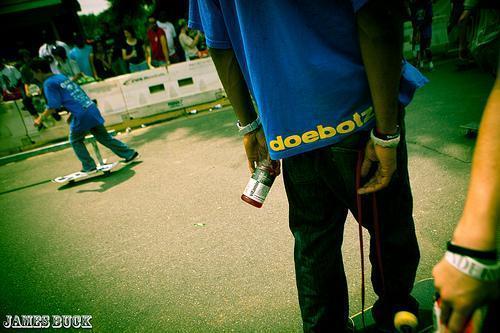How many bottles are shown?
Give a very brief answer. 1. 